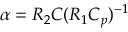Convert formula to latex. <formula><loc_0><loc_0><loc_500><loc_500>\alpha = { R _ { 2 } C } ( { R _ { 1 } C _ { p } } ) ^ { - 1 }</formula> 